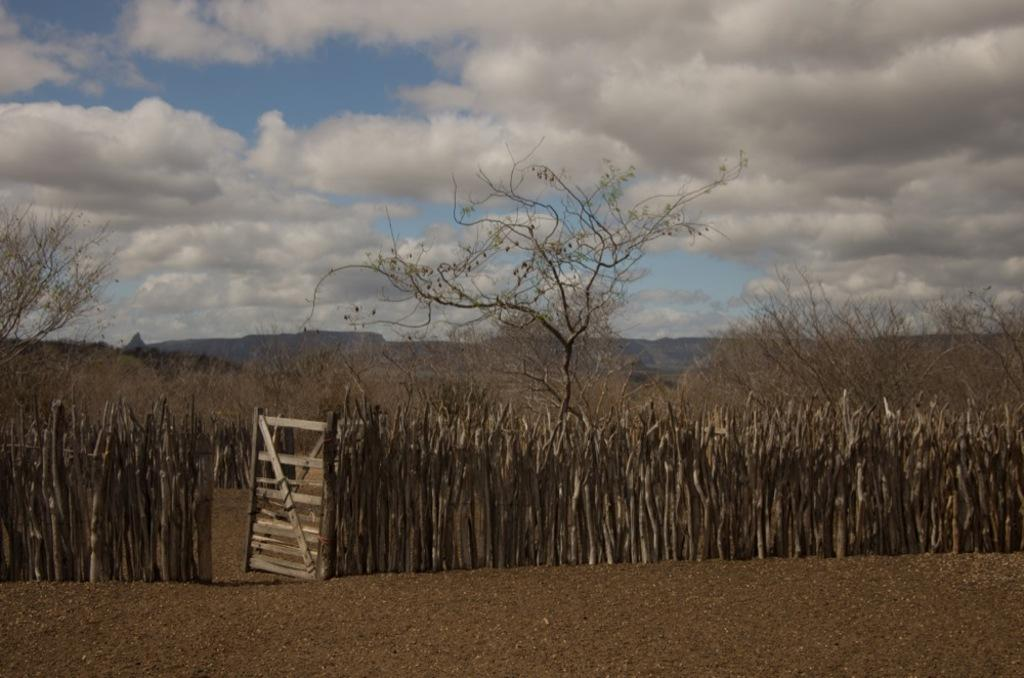What type of door is visible in the image? There is a wooden door in the image. What kind of fencing is present in the image? There is wooden stick fencing in the image. What can be found inside the wooden fencing? Dry trees are present inside the wooden fencing. What can be seen in the distance in the image? There are mountains visible in the background of the image. How many worms are crawling on the wooden door in the image? There are no worms present on the wooden door in the image. What type of riddle is depicted on the wooden door in the image? There is no riddle depicted on the wooden door in the image. 